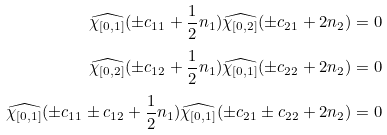<formula> <loc_0><loc_0><loc_500><loc_500>\widehat { \chi _ { [ 0 , 1 ] } } ( \pm c _ { 1 1 } + \frac { 1 } { 2 } n _ { 1 } ) \widehat { \chi _ { [ 0 , 2 ] } } ( \pm c _ { 2 1 } + 2 n _ { 2 } ) & = 0 \\ \widehat { \chi _ { [ 0 , 2 ] } } ( \pm c _ { 1 2 } + \frac { 1 } { 2 } n _ { 1 } ) \widehat { \chi _ { [ 0 , 1 ] } } ( \pm c _ { 2 2 } + 2 n _ { 2 } ) & = 0 \\ \widehat { \chi _ { [ 0 , 1 ] } } ( \pm c _ { 1 1 } \pm c _ { 1 2 } + \frac { 1 } { 2 } n _ { 1 } ) \widehat { \chi _ { [ 0 , 1 ] } } ( \pm c _ { 2 1 } \pm c _ { 2 2 } + 2 n _ { 2 } ) & = 0</formula> 